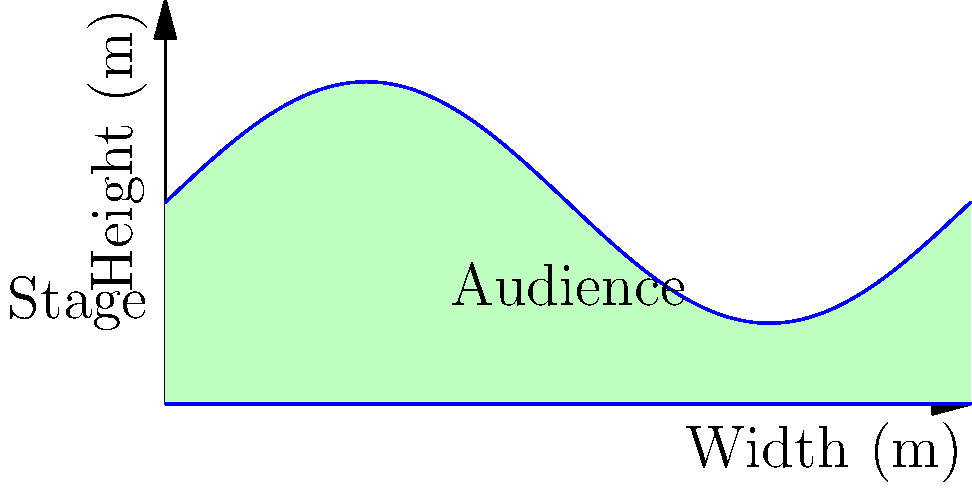The cross-section of an innovative opera hall is shown above, where the ceiling is modeled by the function $h(x) = 5 + 3\sin(\frac{\pi x}{10})$ meters, with $x$ representing the distance from the stage in meters. If the hall is 15 meters wide, calculate the volume of air in the hall, assuming it has a constant depth of 25 meters. How does this volume compare to a rectangular hall of the same width, depth, and average height? Let's approach this step-by-step:

1) The volume of the hall can be found by integrating the area of the cross-section over the depth of the hall.

2) The area of the cross-section is given by:

   $$A = \int_0^{15} (5 + 3\sin(\frac{\pi x}{10})) dx$$

3) Let's solve this integral:
   $$A = [5x - \frac{30}{\pi}\cos(\frac{\pi x}{10})]_0^{15}$$
   $$A = (75 - \frac{30}{\pi}\cos(\frac{3\pi}{2})) - (0 - \frac{30}{\pi}\cos(0))$$
   $$A = 75 - \frac{30}{\pi}(0) - 0 + \frac{30}{\pi} = 75 + \frac{30}{\pi}$$

4) The volume is this area multiplied by the depth:
   $$V = (75 + \frac{30}{\pi}) * 25 = 1875 + \frac{750}{\pi}$$ cubic meters

5) For comparison, let's calculate the average height:
   $$h_{avg} = \frac{1}{15}\int_0^{15} (5 + 3\sin(\frac{\pi x}{10})) dx = 5 + \frac{2}{\pi}$$ meters

6) The volume of a rectangular hall with this average height would be:
   $$V_{rect} = 15 * 25 * (5 + \frac{2}{\pi}) = 1875 + \frac{750}{\pi}$$ cubic meters

7) Interestingly, these volumes are exactly the same, demonstrating a property of sinusoidal functions.
Answer: $1875 + \frac{750}{\pi}$ cubic meters; equal to rectangular hall 